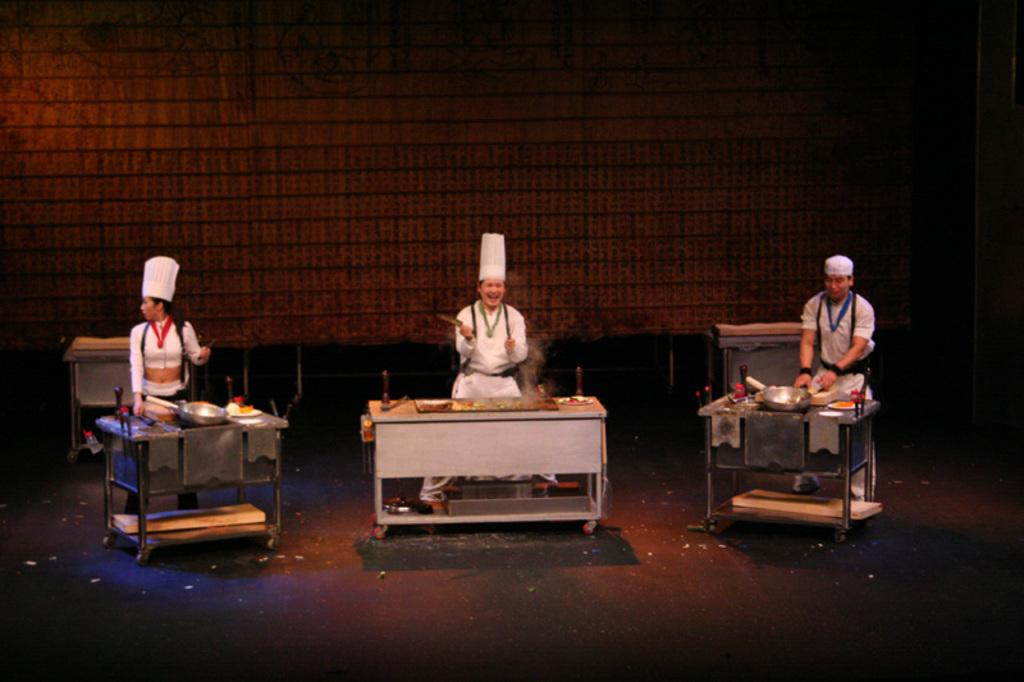How many people are in the image? There are three persons in the image. What are the persons doing in the image? The persons are standing. What color are the dresses worn by the persons in the image? The persons are wearing white color dresses. What objects can be seen in the image besides the persons? There are utensils and tables visible in the image. What is the color of the background in the image? The background of the image is brown in color. Are there any servants carrying bags in the image? There is no mention of servants or bags in the image; it only features three persons wearing white dresses, standing, and surrounded by utensils and tables. What type of play is being performed by the persons in the image? There is no indication of a play or any performance in the image; the persons are simply standing and wearing white dresses. 